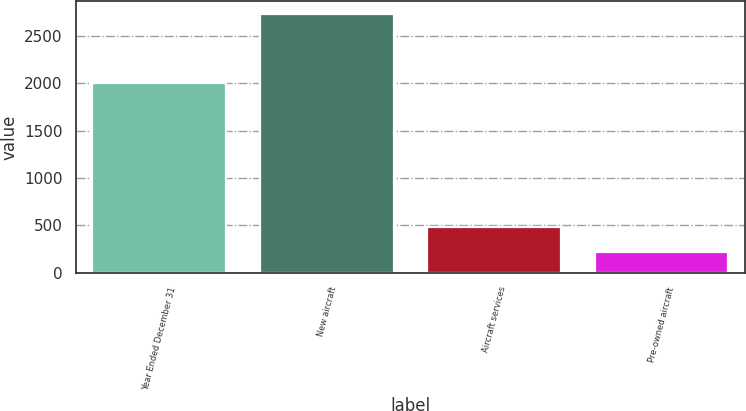Convert chart. <chart><loc_0><loc_0><loc_500><loc_500><bar_chart><fcel>Year Ended December 31<fcel>New aircraft<fcel>Aircraft services<fcel>Pre-owned aircraft<nl><fcel>2005<fcel>2730<fcel>484<fcel>219<nl></chart> 